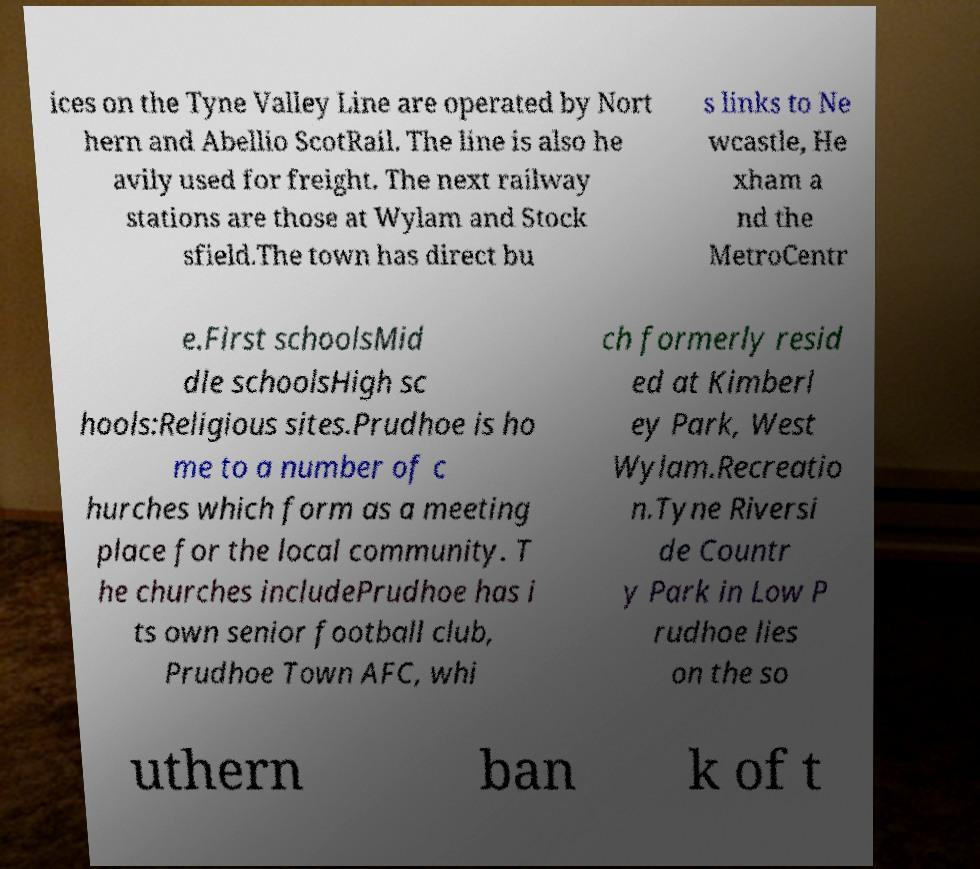Could you extract and type out the text from this image? ices on the Tyne Valley Line are operated by Nort hern and Abellio ScotRail. The line is also he avily used for freight. The next railway stations are those at Wylam and Stock sfield.The town has direct bu s links to Ne wcastle, He xham a nd the MetroCentr e.First schoolsMid dle schoolsHigh sc hools:Religious sites.Prudhoe is ho me to a number of c hurches which form as a meeting place for the local community. T he churches includePrudhoe has i ts own senior football club, Prudhoe Town AFC, whi ch formerly resid ed at Kimberl ey Park, West Wylam.Recreatio n.Tyne Riversi de Countr y Park in Low P rudhoe lies on the so uthern ban k of t 